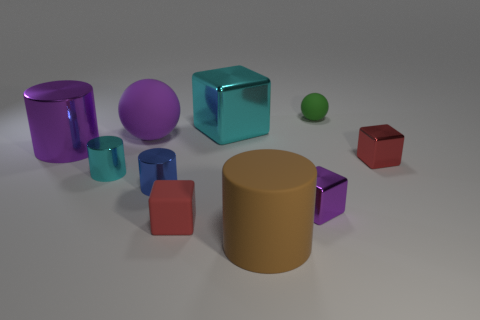There is a small object that is the same color as the big sphere; what is its shape?
Your response must be concise. Cube. There is a big matte thing that is behind the large purple shiny object; is its color the same as the big shiny cylinder?
Your response must be concise. Yes. Are the tiny thing left of the tiny blue object and the cylinder right of the cyan block made of the same material?
Make the answer very short. No. What shape is the cyan metallic thing that is in front of the small red shiny thing that is behind the big brown rubber object?
Your response must be concise. Cylinder. What is the color of the large cylinder that is the same material as the large cyan object?
Offer a very short reply. Purple. Is the large metal block the same color as the large ball?
Your response must be concise. No. What shape is the matte thing that is the same size as the rubber cylinder?
Offer a terse response. Sphere. The red rubber cube is what size?
Make the answer very short. Small. Do the metal block on the left side of the matte cylinder and the red block left of the green thing have the same size?
Your answer should be very brief. No. The large metal thing that is right of the rubber sphere that is left of the matte cylinder is what color?
Your response must be concise. Cyan. 